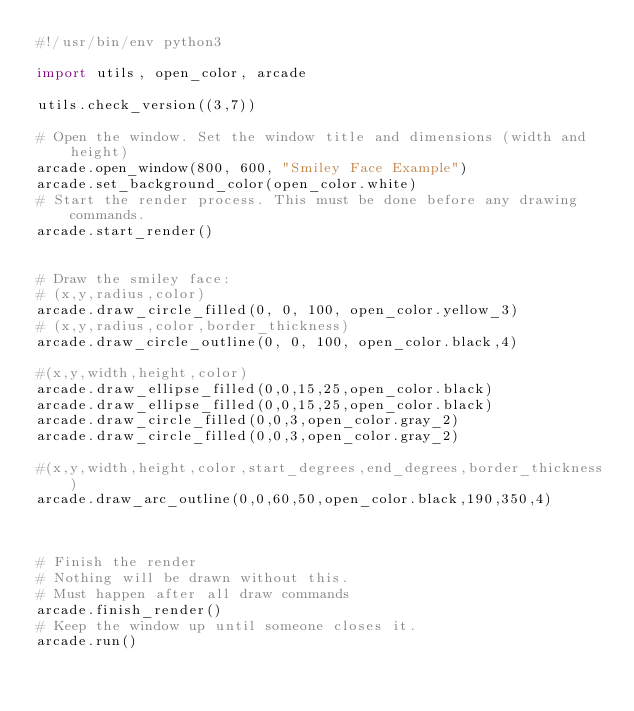<code> <loc_0><loc_0><loc_500><loc_500><_Python_>#!/usr/bin/env python3

import utils, open_color, arcade

utils.check_version((3,7))

# Open the window. Set the window title and dimensions (width and height)
arcade.open_window(800, 600, "Smiley Face Example")
arcade.set_background_color(open_color.white)
# Start the render process. This must be done before any drawing commands.
arcade.start_render()


# Draw the smiley face:
# (x,y,radius,color)
arcade.draw_circle_filled(0, 0, 100, open_color.yellow_3)
# (x,y,radius,color,border_thickness)
arcade.draw_circle_outline(0, 0, 100, open_color.black,4)

#(x,y,width,height,color)
arcade.draw_ellipse_filled(0,0,15,25,open_color.black)
arcade.draw_ellipse_filled(0,0,15,25,open_color.black)
arcade.draw_circle_filled(0,0,3,open_color.gray_2)
arcade.draw_circle_filled(0,0,3,open_color.gray_2)

#(x,y,width,height,color,start_degrees,end_degrees,border_thickness)
arcade.draw_arc_outline(0,0,60,50,open_color.black,190,350,4)



# Finish the render
# Nothing will be drawn without this.
# Must happen after all draw commands
arcade.finish_render()
# Keep the window up until someone closes it.
arcade.run()
</code> 